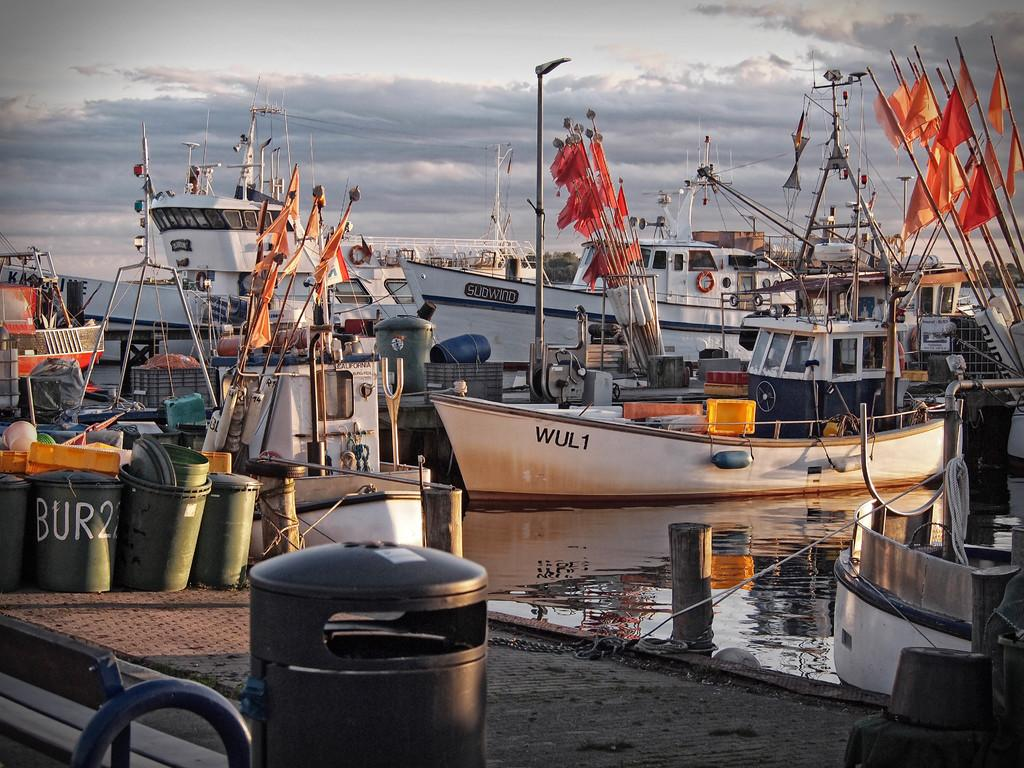<image>
Create a compact narrative representing the image presented. A white boat has the letters "WUL1" on the side. 